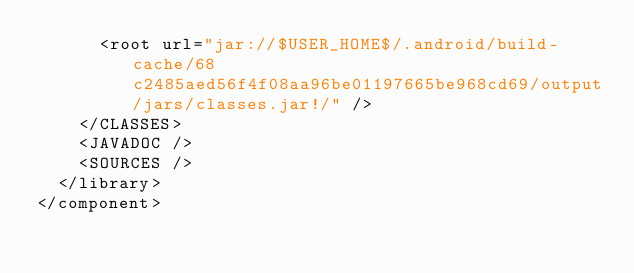Convert code to text. <code><loc_0><loc_0><loc_500><loc_500><_XML_>      <root url="jar://$USER_HOME$/.android/build-cache/68c2485aed56f4f08aa96be01197665be968cd69/output/jars/classes.jar!/" />
    </CLASSES>
    <JAVADOC />
    <SOURCES />
  </library>
</component></code> 